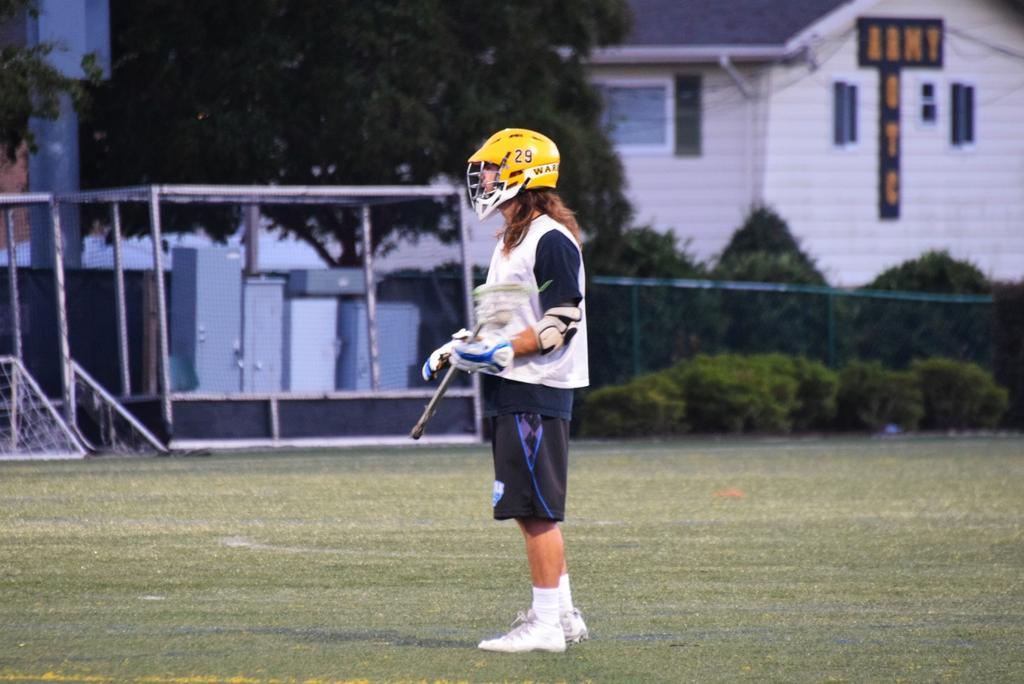In one or two sentences, can you explain what this image depicts? In the center of the image we can see a person standing on a grass. In the background we can see fencing, trees, plants, house and grass. 